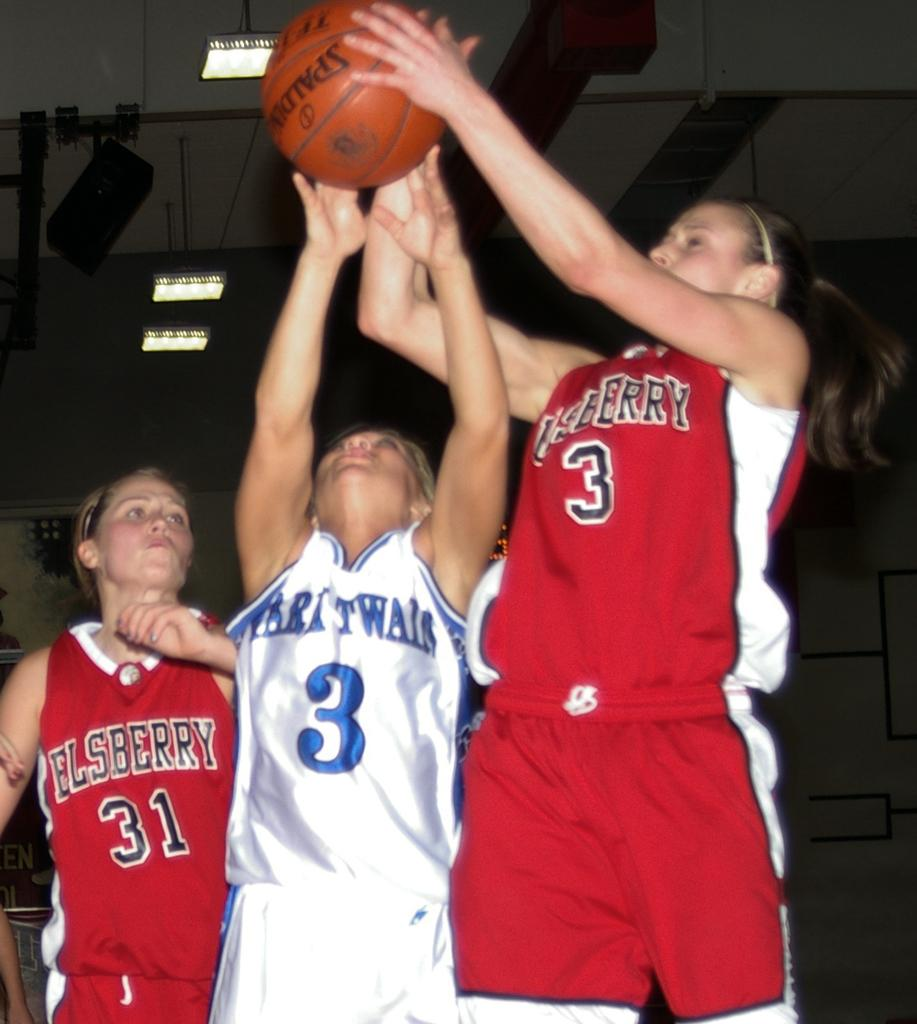<image>
Write a terse but informative summary of the picture. Woman wearing a red number 3 jersey fighting for a ball with another girl. 